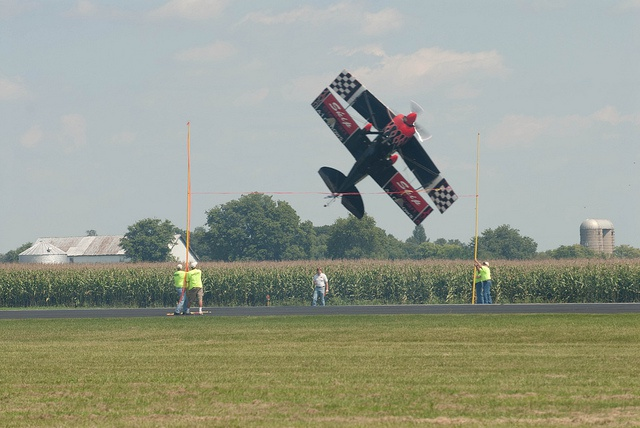Describe the objects in this image and their specific colors. I can see airplane in darkgray, navy, darkblue, and gray tones, people in darkgray, gray, khaki, and olive tones, people in darkgray, gray, olive, and khaki tones, people in darkgray, gray, and lightgray tones, and people in darkgray, blue, khaki, and gray tones in this image. 